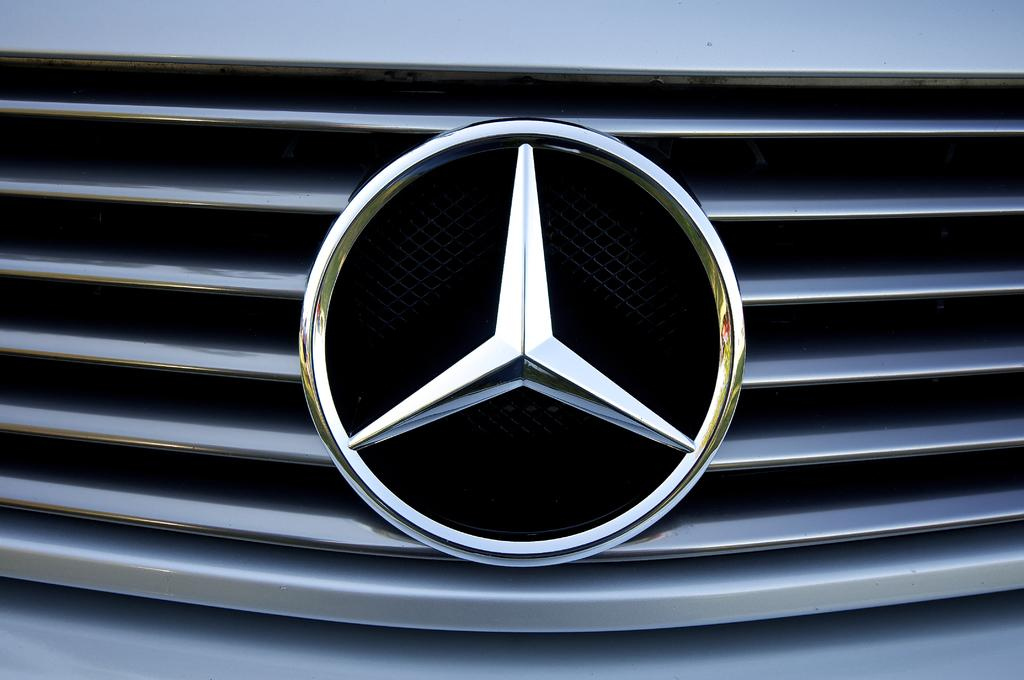What is the main subject of the image? The main subject of the image is a Mercedes Emblem. Where is the emblem located in the image? The emblem is on a car. Can you describe the bit that the car is using to cause an earthquake in the image? There is no bit or earthquake depicted in the image; it simply shows a Mercedes Emblem on a car. 